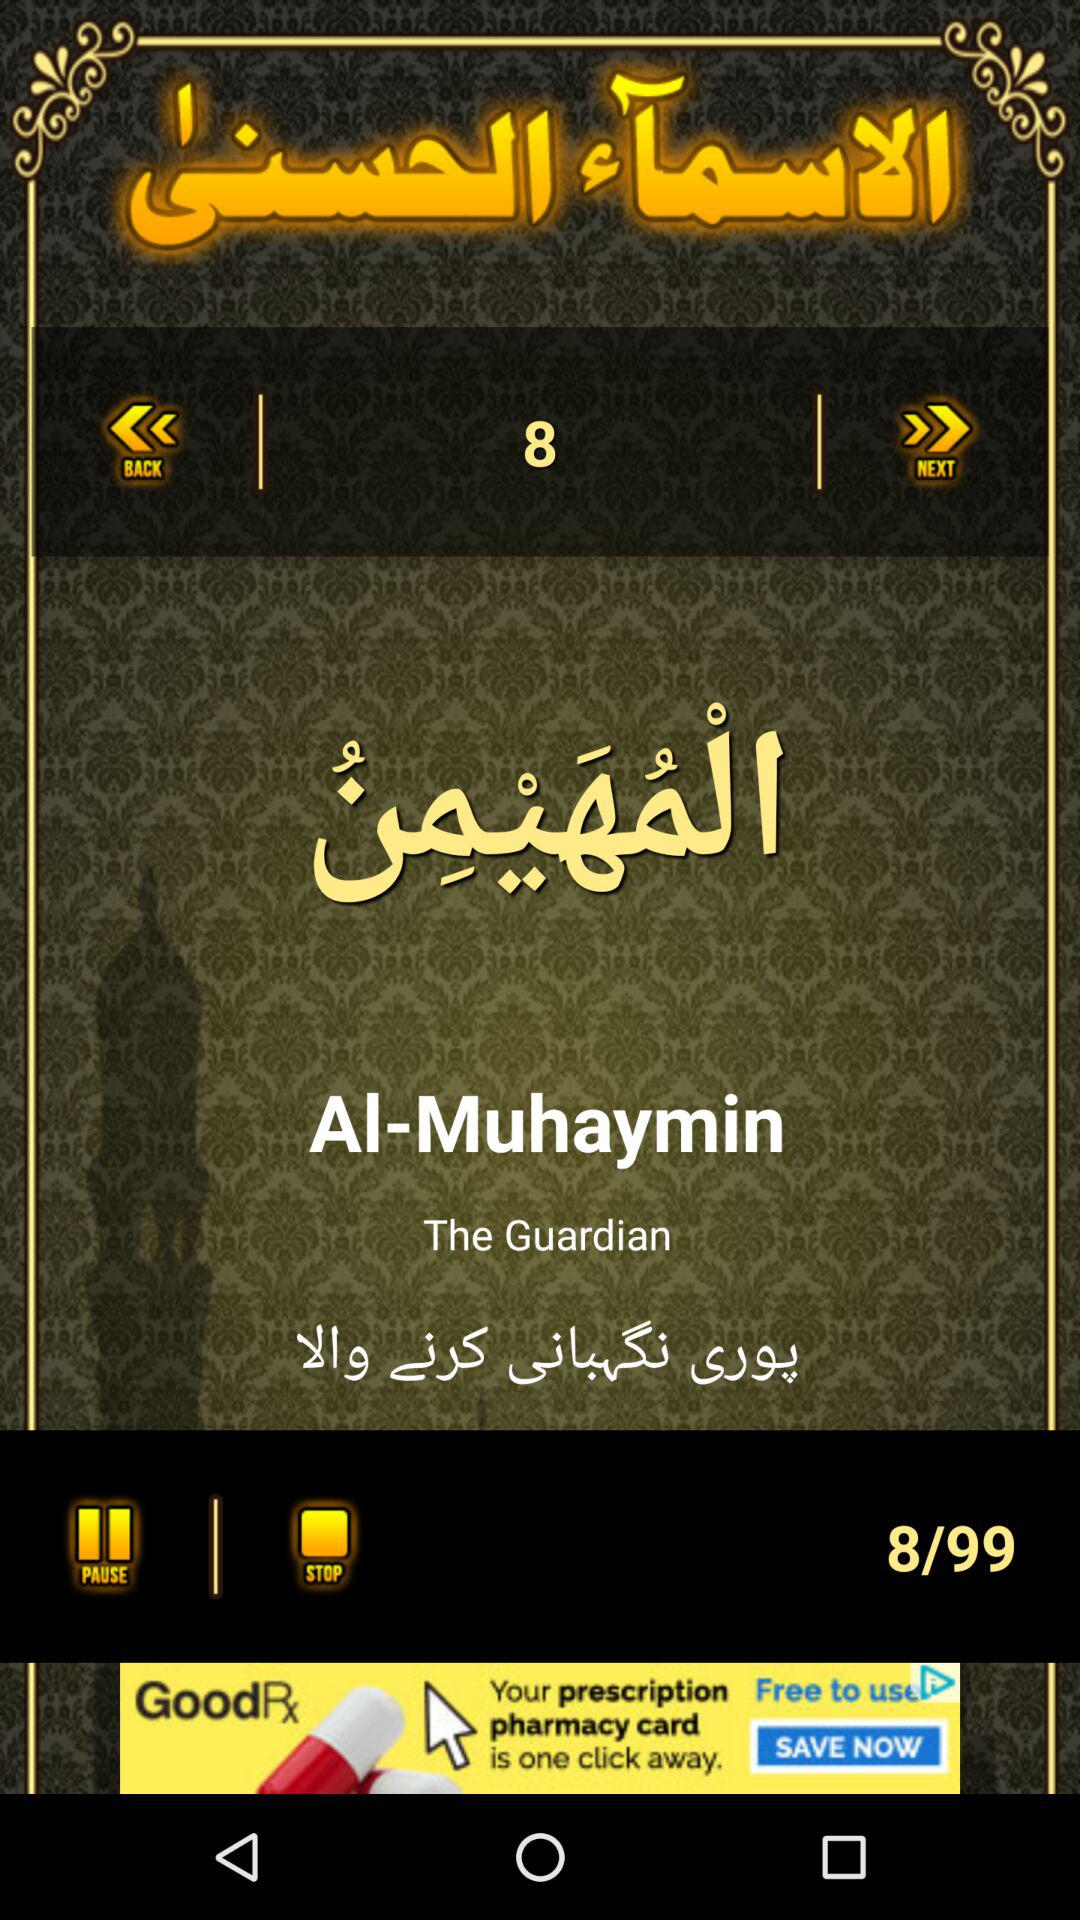Which song number am I at? You are on song number 8. 